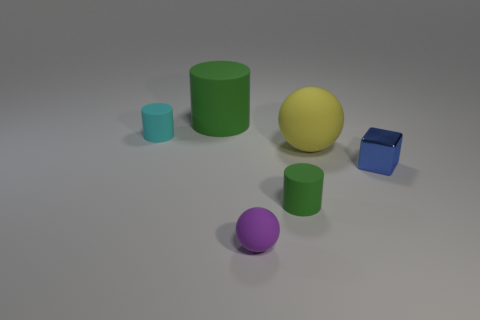Subtract all large green matte cylinders. How many cylinders are left? 2 Subtract all blocks. How many objects are left? 5 Add 3 gray cubes. How many objects exist? 9 Add 5 yellow things. How many yellow things are left? 6 Add 2 small gray rubber balls. How many small gray rubber balls exist? 2 Subtract 0 red spheres. How many objects are left? 6 Subtract all yellow matte balls. Subtract all balls. How many objects are left? 3 